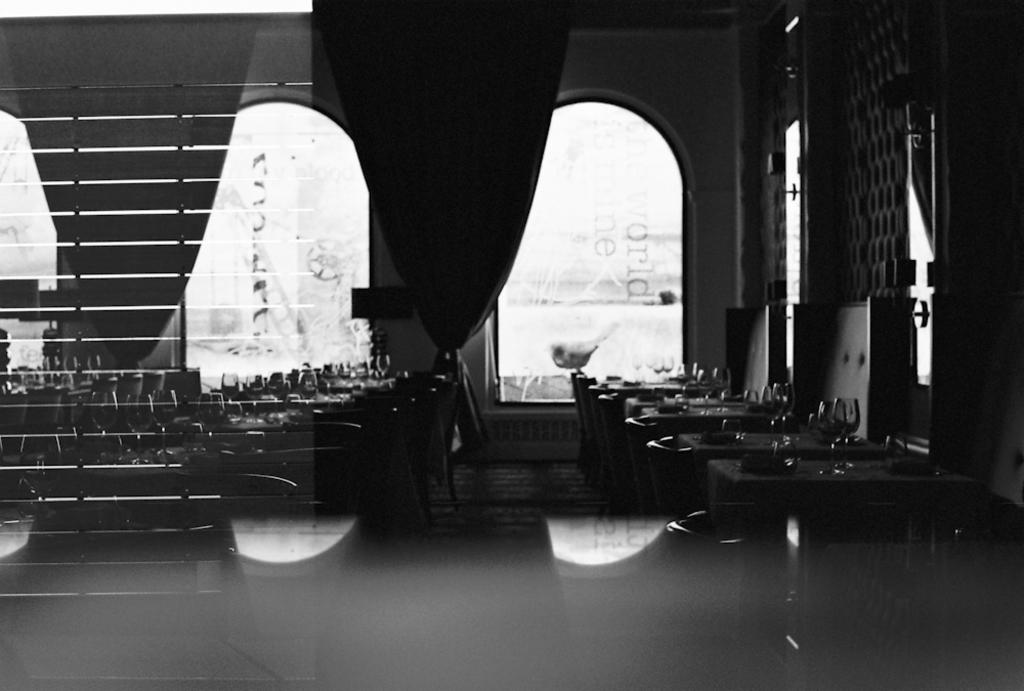What type of location is depicted in the image? The image shows the inside of a building. What architectural feature can be seen in the image? There are windows visible in the image. What objects are present in the image? There are glasses present in the image. Can you tell me how many giraffes are visible through the windows in the image? There are no giraffes visible through the windows in the image. What type of lumber is used to construct the building in the image? The image does not provide information about the type of lumber used to construct the building. 